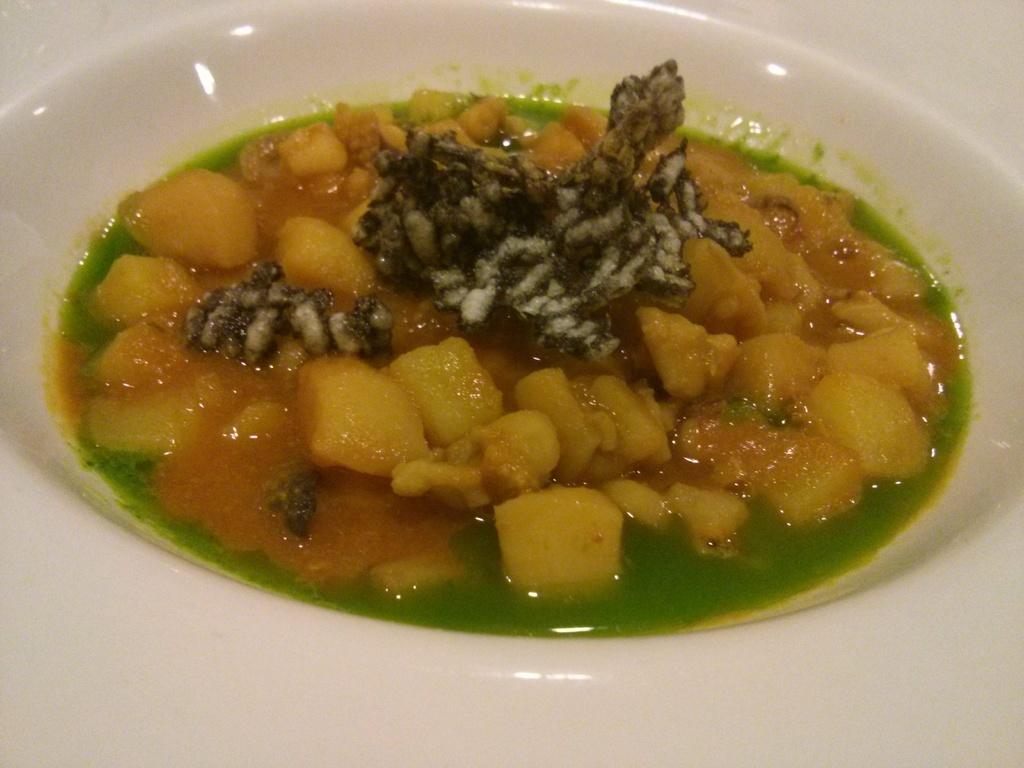In one or two sentences, can you explain what this image depicts? In this image there is a plate. There is food on the plate. 